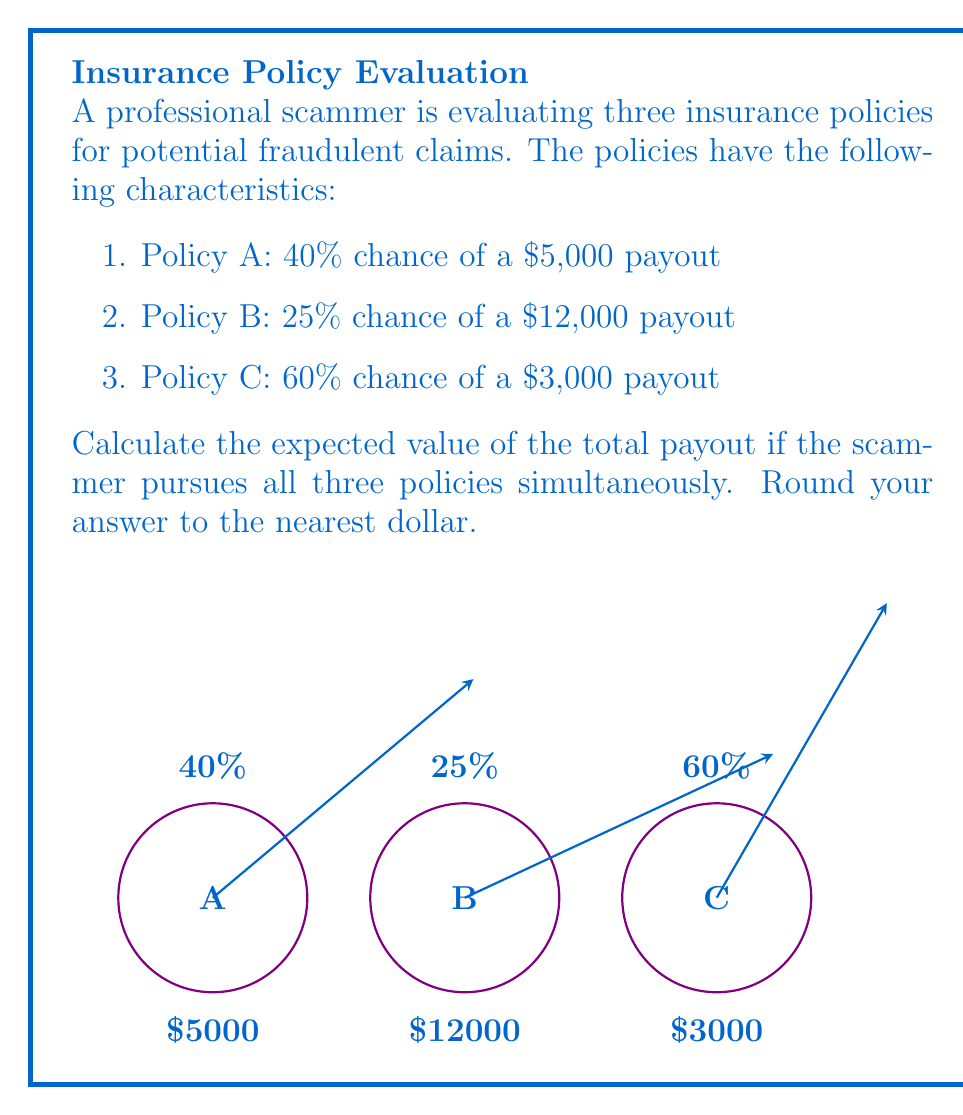Can you solve this math problem? To calculate the expected value of the total payout, we need to:
1. Calculate the expected value for each policy
2. Sum up the expected values

Let's go through this step-by-step:

1. Expected value for Policy A:
   $E(A) = 0.40 \times \$5,000 = \$2,000$

2. Expected value for Policy B:
   $E(B) = 0.25 \times \$12,000 = \$3,000$

3. Expected value for Policy C:
   $E(C) = 0.60 \times \$3,000 = \$1,800$

4. Total expected value:
   $E(Total) = E(A) + E(B) + E(C)$
   $E(Total) = \$2,000 + \$3,000 + \$1,800 = \$6,800$

The expected value represents the average amount the scammer would receive if they pursued these policies many times over. It's calculated by multiplying the probability of each outcome by its corresponding payout and then summing these products.

Rounding to the nearest dollar, the final answer remains $6,800.
Answer: $6,800 